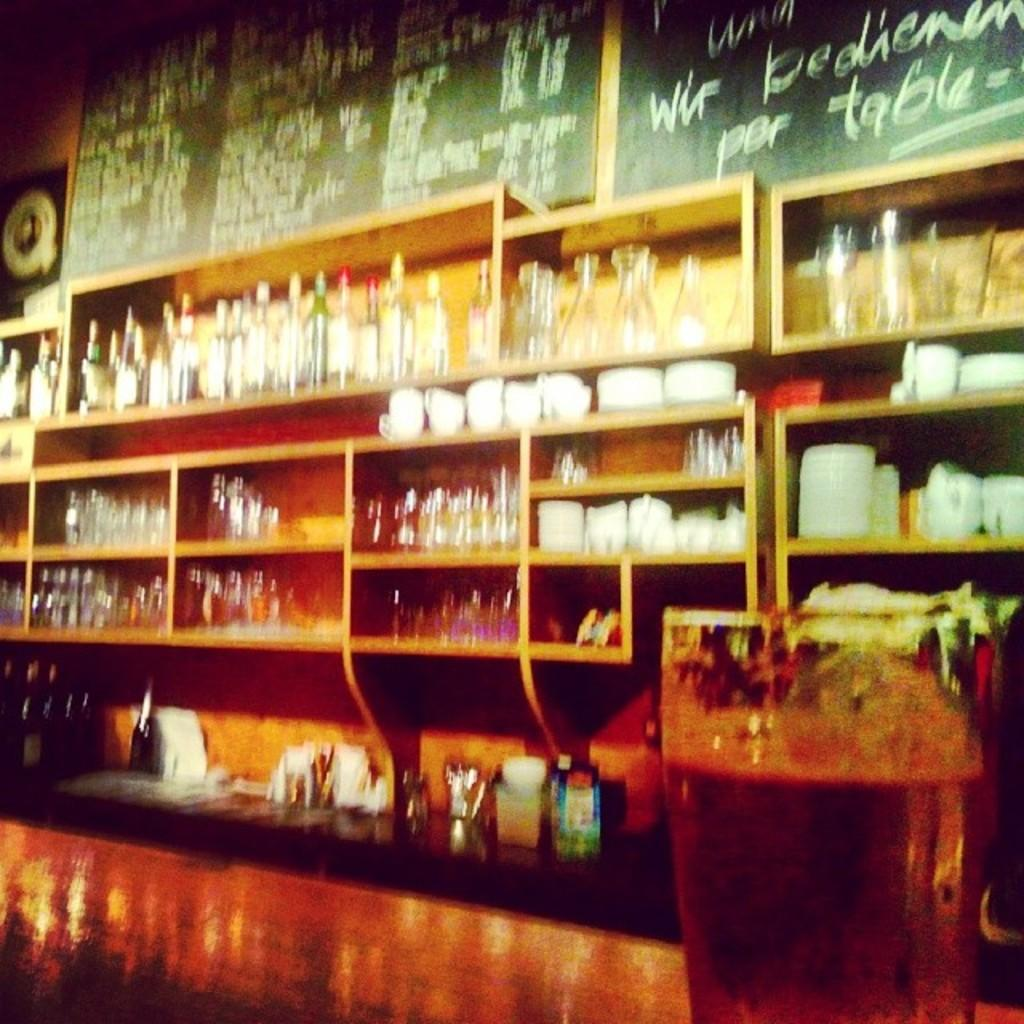<image>
Give a short and clear explanation of the subsequent image. A blurry image show a blackboard with table written on the lower right corner. 